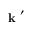Convert formula to latex. <formula><loc_0><loc_0><loc_500><loc_500>k ^ { \prime }</formula> 